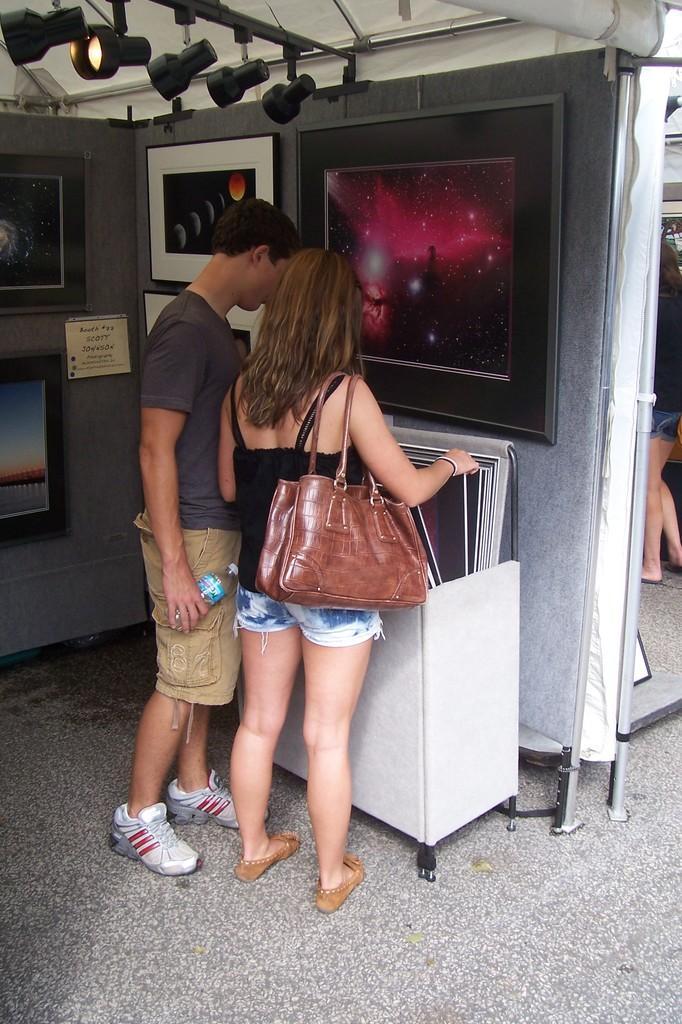How would you summarize this image in a sentence or two? This man is holding a bottle. This woman wore handbag. In-front of this person's there is a box with photos. On wall there are different type of pictures. On top there is a focusing light. Far the other person is standing. 